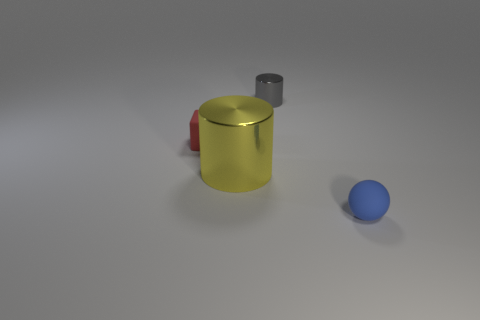Add 2 blue metal cylinders. How many objects exist? 6 Subtract all blocks. How many objects are left? 3 Add 2 tiny balls. How many tiny balls are left? 3 Add 1 yellow objects. How many yellow objects exist? 2 Subtract 0 blue cubes. How many objects are left? 4 Subtract all large red metal objects. Subtract all gray objects. How many objects are left? 3 